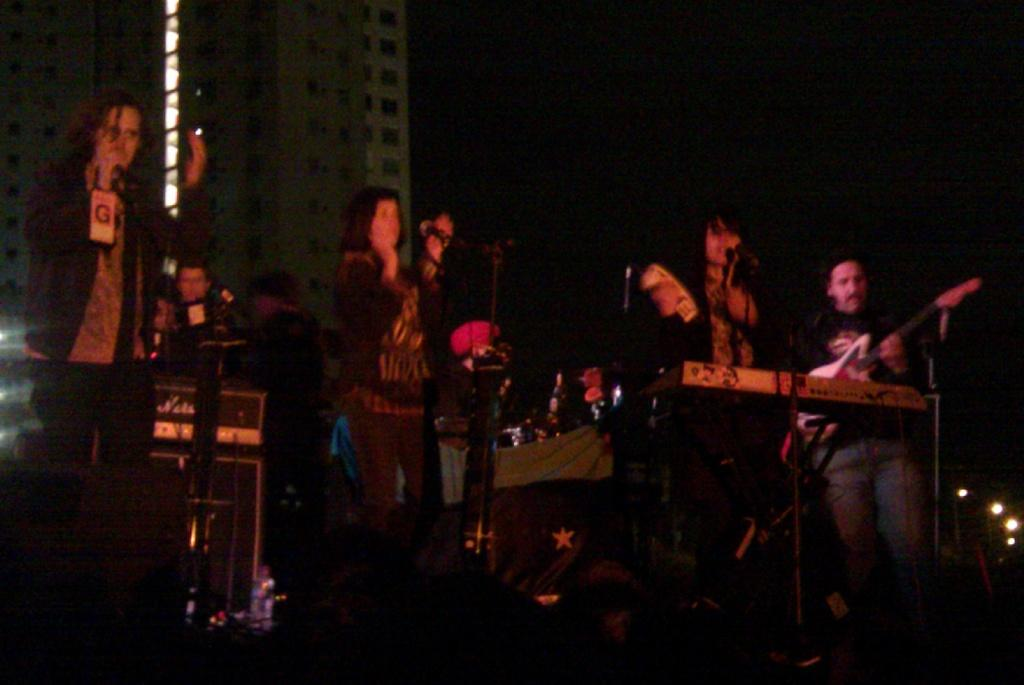What is the main subject of the image? The main subject of the image is a group of people. What else can be seen in the image besides the people? Musical instruments and buildings are present in the image. How would you describe the lighting in the image? The background of the image appears to be dark. Can you see any volcanoes erupting in the background of the image? There are no volcanoes present in the image, so it is not possible to see any eruptions. 